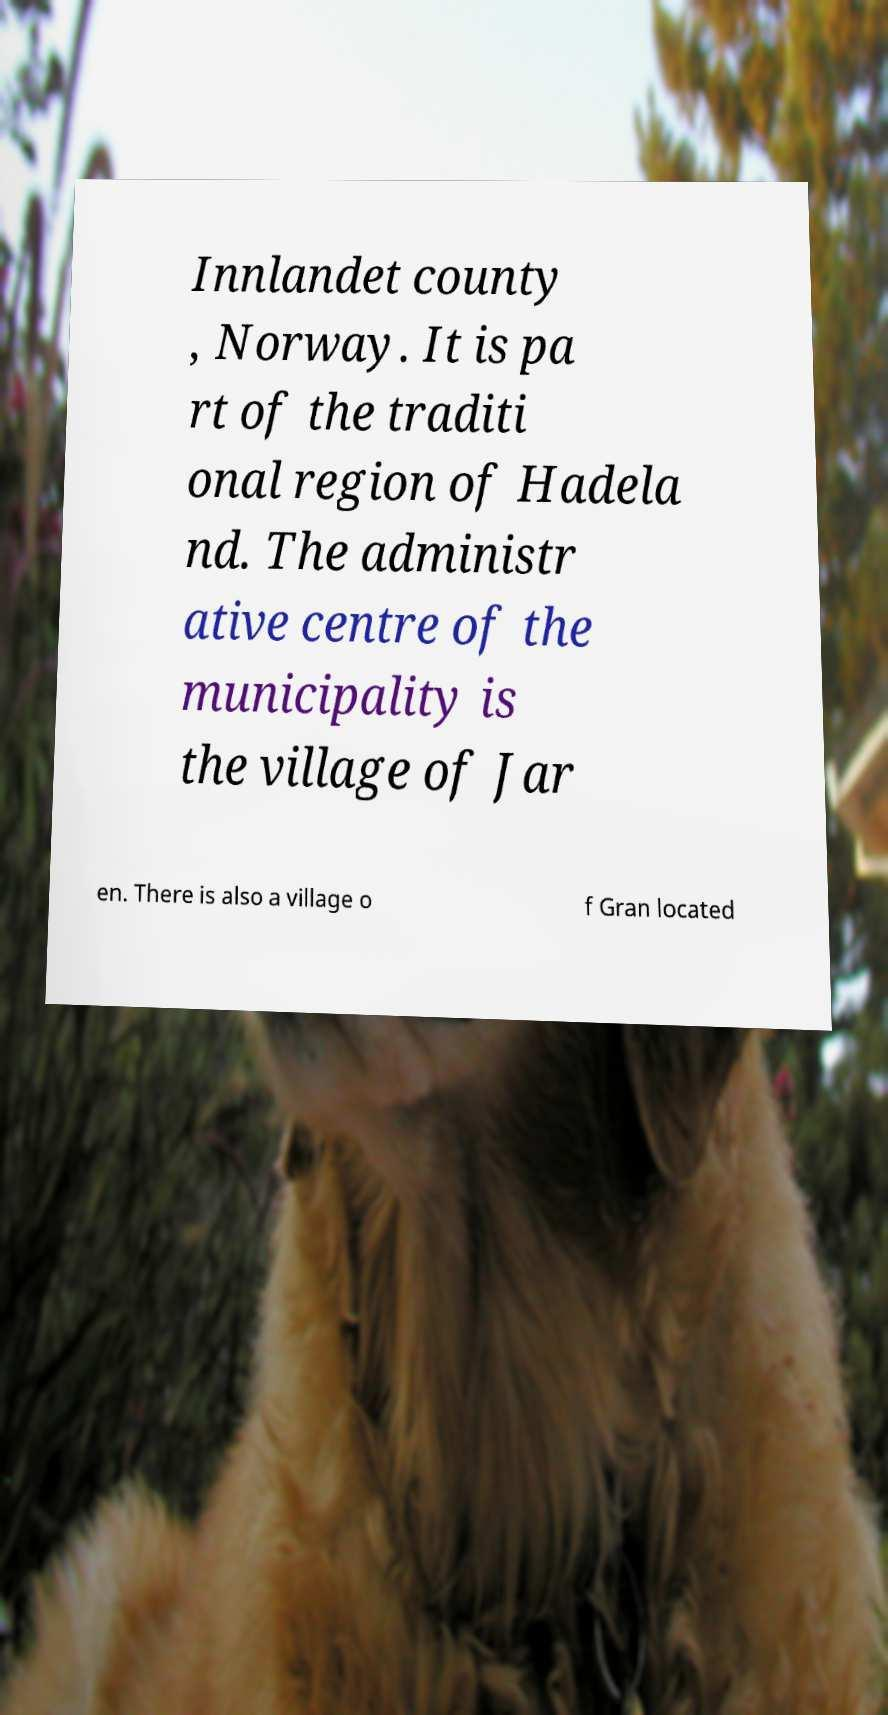Could you assist in decoding the text presented in this image and type it out clearly? Innlandet county , Norway. It is pa rt of the traditi onal region of Hadela nd. The administr ative centre of the municipality is the village of Jar en. There is also a village o f Gran located 